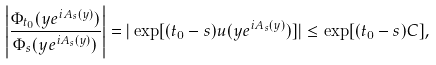<formula> <loc_0><loc_0><loc_500><loc_500>\left | \frac { \Phi _ { t _ { 0 } } ( y e ^ { i A _ { s } ( y ) } ) } { \Phi _ { s } ( y e ^ { i A _ { s } ( y ) } ) } \right | = | \exp [ ( t _ { 0 } - s ) u ( y e ^ { i A _ { s } ( y ) } ) ] | \leq \exp [ ( t _ { 0 } - s ) C ] ,</formula> 